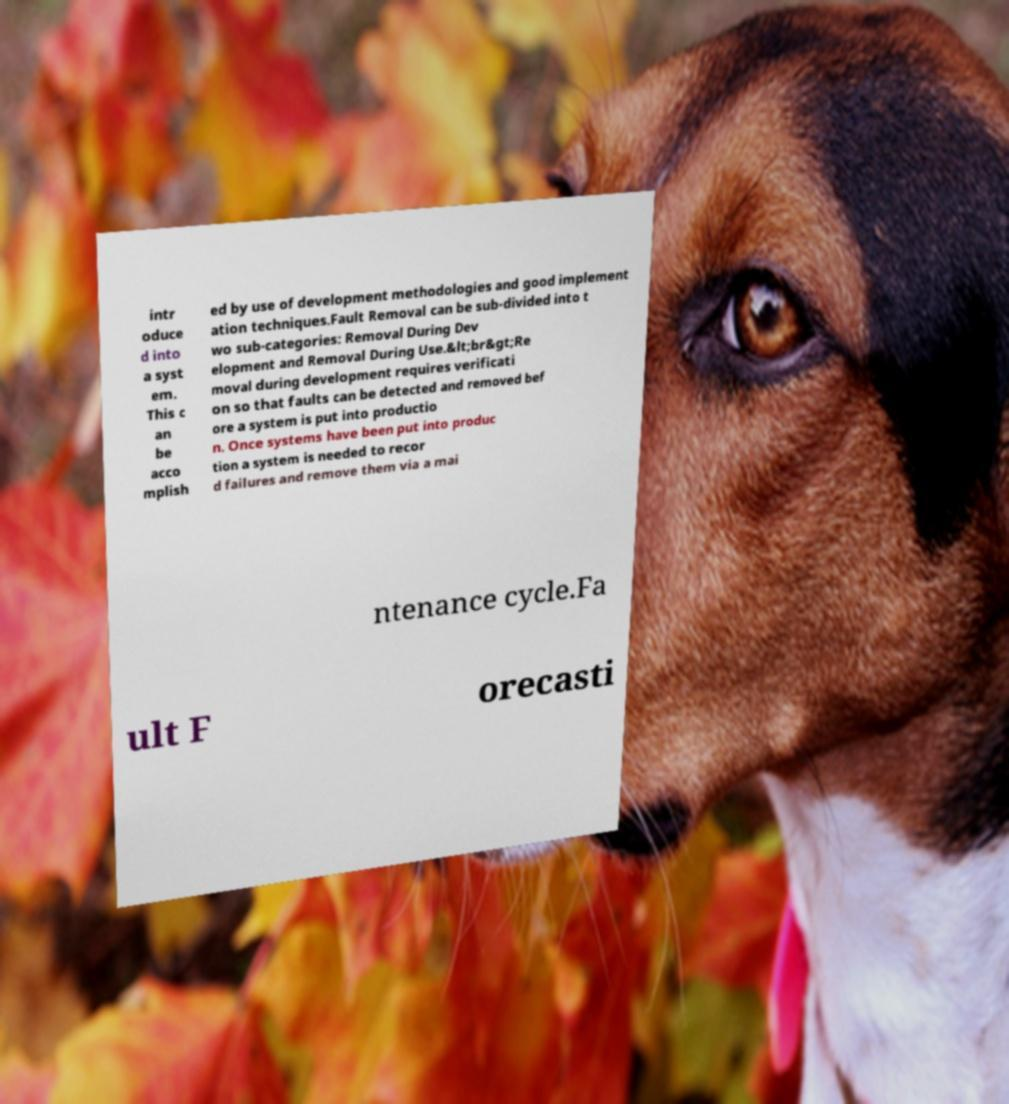What messages or text are displayed in this image? I need them in a readable, typed format. intr oduce d into a syst em. This c an be acco mplish ed by use of development methodologies and good implement ation techniques.Fault Removal can be sub-divided into t wo sub-categories: Removal During Dev elopment and Removal During Use.&lt;br&gt;Re moval during development requires verificati on so that faults can be detected and removed bef ore a system is put into productio n. Once systems have been put into produc tion a system is needed to recor d failures and remove them via a mai ntenance cycle.Fa ult F orecasti 